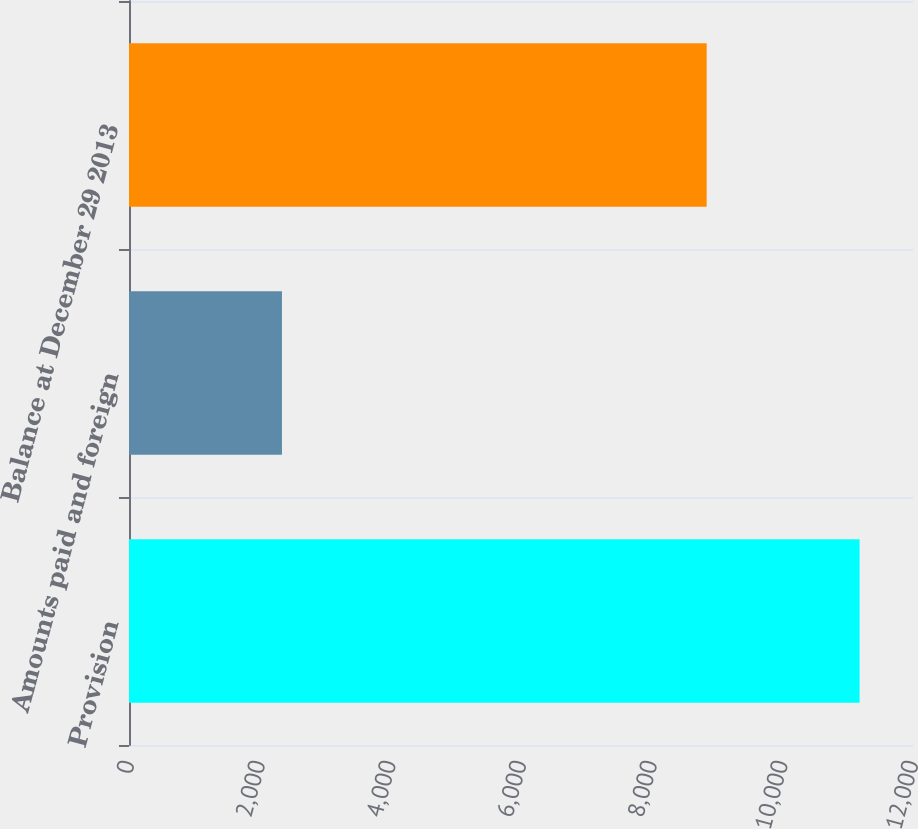Convert chart to OTSL. <chart><loc_0><loc_0><loc_500><loc_500><bar_chart><fcel>Provision<fcel>Amounts paid and foreign<fcel>Balance at December 29 2013<nl><fcel>11183<fcel>2341<fcel>8842<nl></chart> 